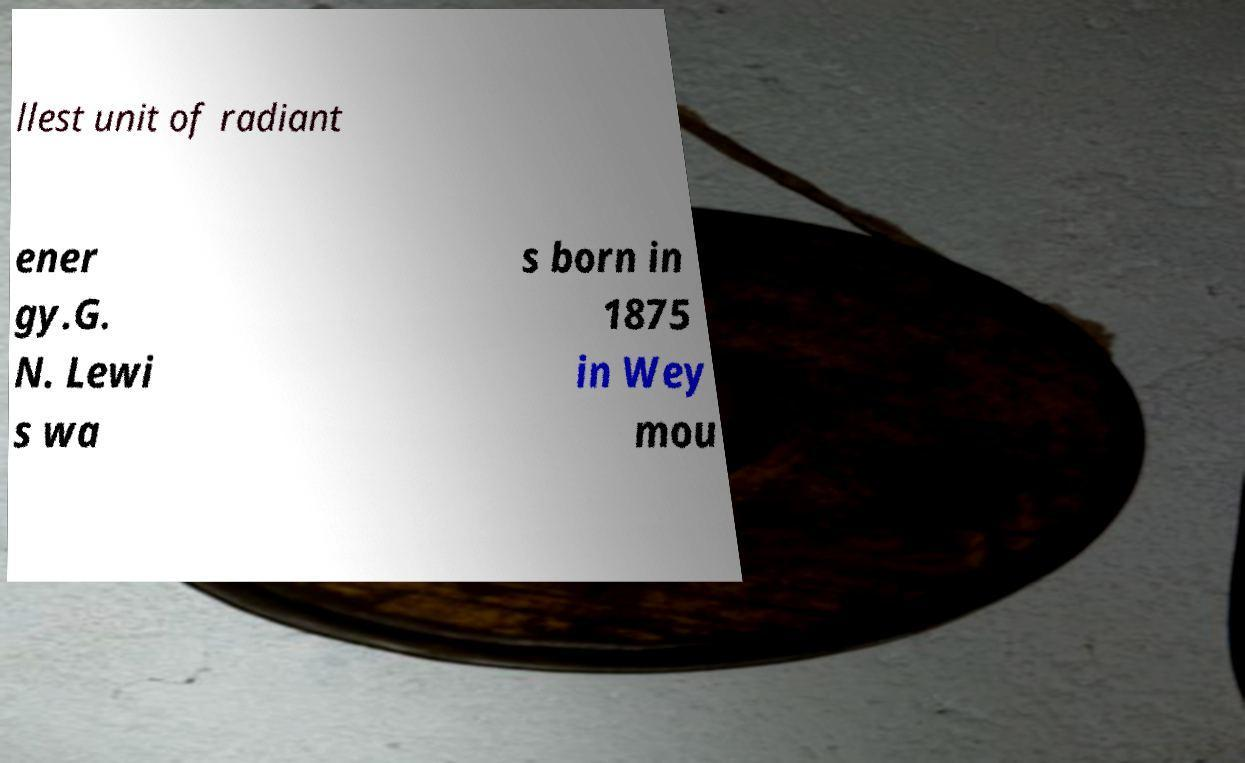Can you accurately transcribe the text from the provided image for me? llest unit of radiant ener gy.G. N. Lewi s wa s born in 1875 in Wey mou 